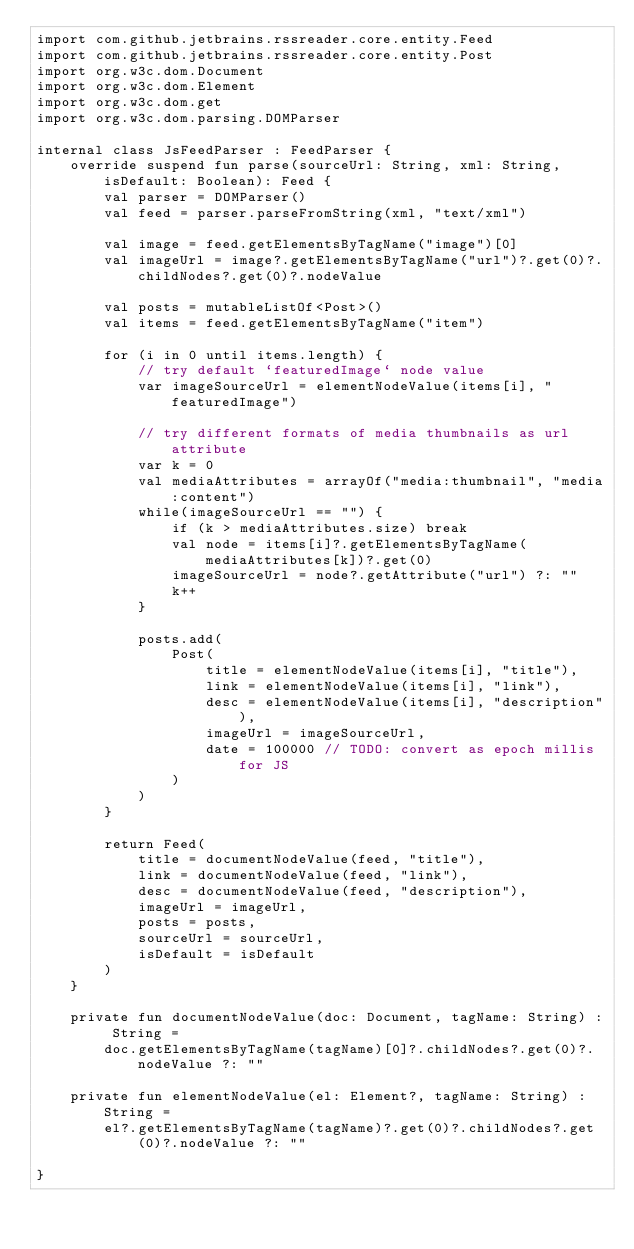<code> <loc_0><loc_0><loc_500><loc_500><_Kotlin_>import com.github.jetbrains.rssreader.core.entity.Feed
import com.github.jetbrains.rssreader.core.entity.Post
import org.w3c.dom.Document
import org.w3c.dom.Element
import org.w3c.dom.get
import org.w3c.dom.parsing.DOMParser

internal class JsFeedParser : FeedParser {
    override suspend fun parse(sourceUrl: String, xml: String, isDefault: Boolean): Feed {
        val parser = DOMParser()
        val feed = parser.parseFromString(xml, "text/xml")

        val image = feed.getElementsByTagName("image")[0]
        val imageUrl = image?.getElementsByTagName("url")?.get(0)?.childNodes?.get(0)?.nodeValue

        val posts = mutableListOf<Post>()
        val items = feed.getElementsByTagName("item")

        for (i in 0 until items.length) {
            // try default `featuredImage` node value
            var imageSourceUrl = elementNodeValue(items[i], "featuredImage")

            // try different formats of media thumbnails as url attribute
            var k = 0
            val mediaAttributes = arrayOf("media:thumbnail", "media:content")
            while(imageSourceUrl == "") {
                if (k > mediaAttributes.size) break
                val node = items[i]?.getElementsByTagName(mediaAttributes[k])?.get(0)
                imageSourceUrl = node?.getAttribute("url") ?: ""
                k++
            }

            posts.add(
                Post(
                    title = elementNodeValue(items[i], "title"),
                    link = elementNodeValue(items[i], "link"),
                    desc = elementNodeValue(items[i], "description"),
                    imageUrl = imageSourceUrl,
                    date = 100000 // TODO: convert as epoch millis for JS
                )
            )
        }

        return Feed(
            title = documentNodeValue(feed, "title"),
            link = documentNodeValue(feed, "link"),
            desc = documentNodeValue(feed, "description"),
            imageUrl = imageUrl,
            posts = posts,
            sourceUrl = sourceUrl,
            isDefault = isDefault
        )
    }

    private fun documentNodeValue(doc: Document, tagName: String) : String =
        doc.getElementsByTagName(tagName)[0]?.childNodes?.get(0)?.nodeValue ?: ""

    private fun elementNodeValue(el: Element?, tagName: String) : String =
        el?.getElementsByTagName(tagName)?.get(0)?.childNodes?.get(0)?.nodeValue ?: ""

}
</code> 